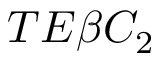Convert formula to latex. <formula><loc_0><loc_0><loc_500><loc_500>T E \beta C _ { 2 }</formula> 